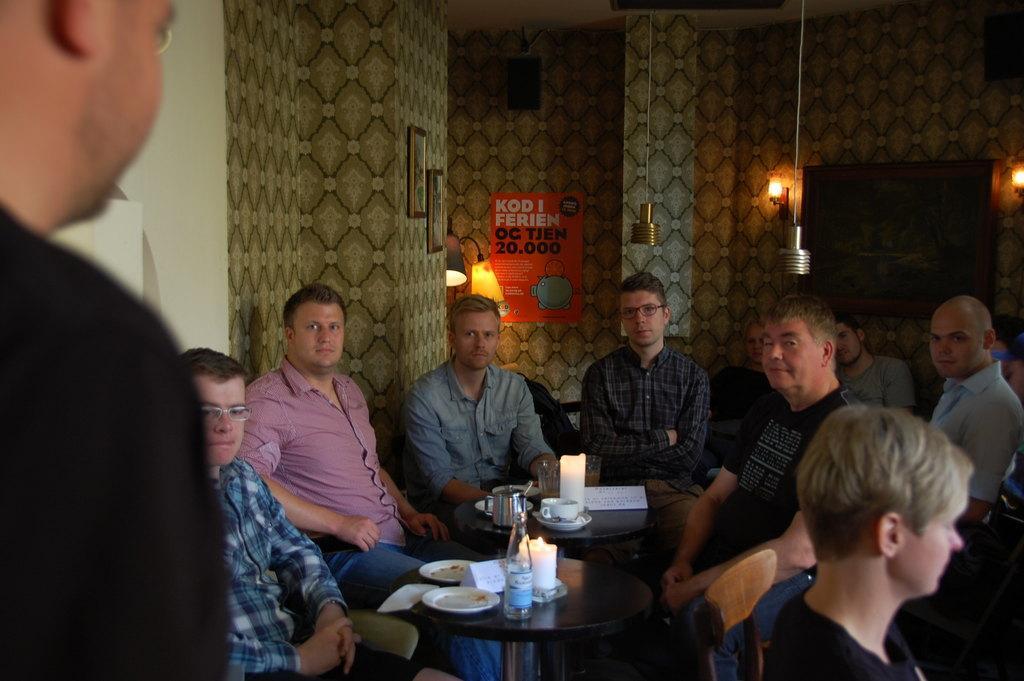Could you give a brief overview of what you see in this image? There is a group of people. They all are sitting in a chair. There is a table. There is a glass,cup saucer,bottle and plate on a table. Some persons are smiling. We can in the background there is a wall. poster and lights. 